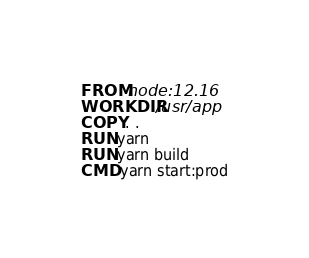Convert code to text. <code><loc_0><loc_0><loc_500><loc_500><_Dockerfile_>FROM node:12.16
WORKDIR /usr/app
COPY . .
RUN yarn
RUN yarn build
CMD yarn start:prod</code> 